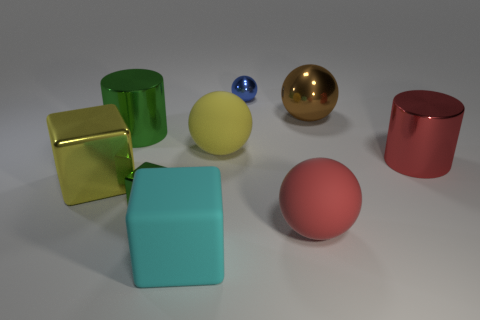What size is the yellow thing left of the matte object in front of the large matte ball on the right side of the large yellow rubber thing?
Offer a terse response. Large. What is the size of the blue thing that is the same shape as the brown object?
Provide a succinct answer. Small. How many big objects are blue matte things or red shiny things?
Give a very brief answer. 1. Are the small object that is in front of the brown object and the sphere behind the big brown metal thing made of the same material?
Provide a short and direct response. Yes. What is the ball in front of the large yellow ball made of?
Provide a succinct answer. Rubber. How many metal things are tiny green objects or balls?
Ensure brevity in your answer.  3. The shiny ball that is right of the big red object that is in front of the large red metallic thing is what color?
Give a very brief answer. Brown. Do the tiny green object and the large cylinder that is on the right side of the large green metal cylinder have the same material?
Give a very brief answer. Yes. What color is the big sphere in front of the big yellow object that is right of the big yellow thing that is left of the cyan rubber block?
Make the answer very short. Red. Is there anything else that has the same shape as the blue metal thing?
Offer a very short reply. Yes. 